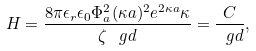<formula> <loc_0><loc_0><loc_500><loc_500>H = \frac { 8 \pi \epsilon _ { r } \epsilon _ { 0 } \Phi _ { a } ^ { 2 } ( \kappa a ) ^ { 2 } e ^ { 2 \kappa a } \kappa } { \zeta \, \ g d } = \frac { C } { \ g d } ,</formula> 